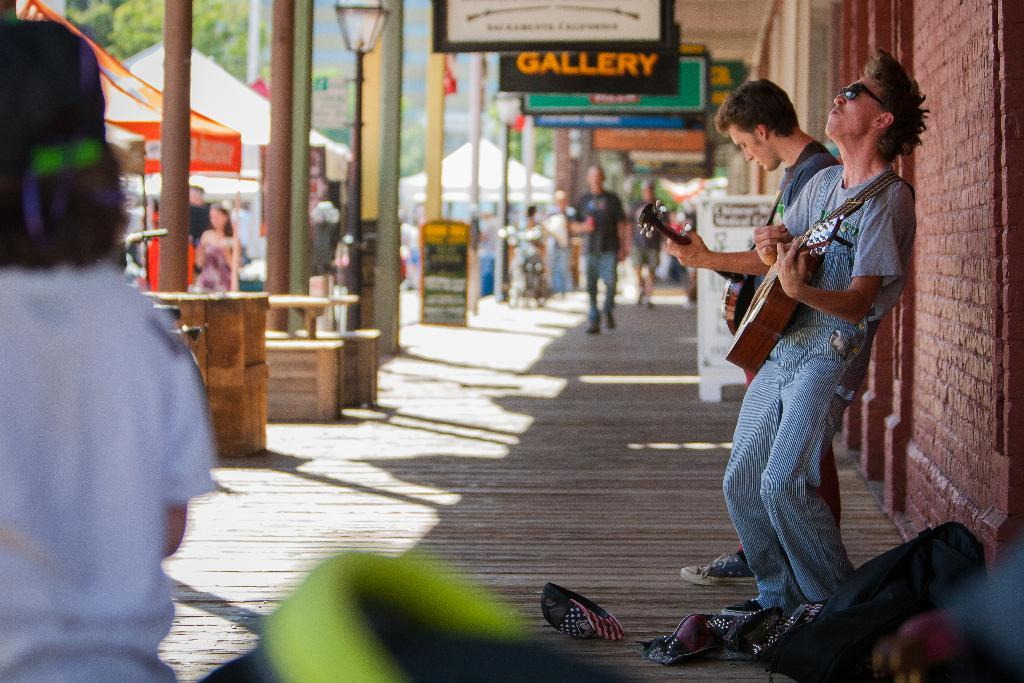How many people are in the image? There are two persons standing in the image. What is one of the persons doing? One of the persons is playing a guitar. What can be seen on the left side of the image? There is a brick wall on the left side of the image. What type of temporary shelters are present in the image? There are tents in the image. What other objects can be seen in the image? There are boards in the image. What type of cheese is being grated on the guitar in the image? There is no cheese or grating activity present in the image. 